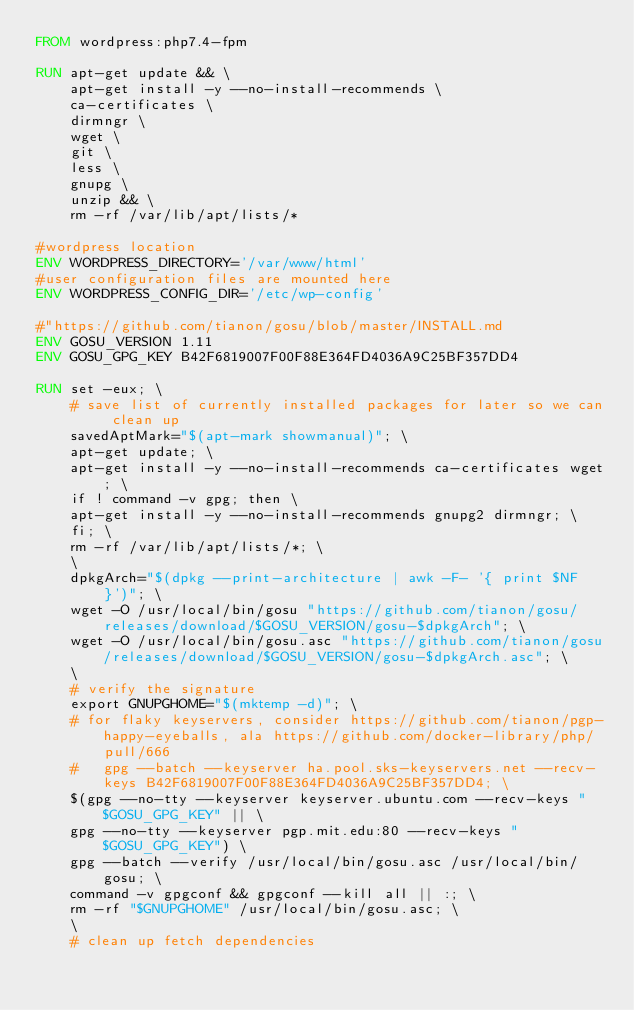<code> <loc_0><loc_0><loc_500><loc_500><_Dockerfile_>FROM wordpress:php7.4-fpm

RUN apt-get update && \
	apt-get install -y --no-install-recommends \
	ca-certificates \
	dirmngr \
	wget \
	git \
	less \
	gnupg \
	unzip && \
	rm -rf /var/lib/apt/lists/*

#wordpress location
ENV WORDPRESS_DIRECTORY='/var/www/html'
#user configuration files are mounted here
ENV WORDPRESS_CONFIG_DIR='/etc/wp-config'

#"https://github.com/tianon/gosu/blob/master/INSTALL.md
ENV GOSU_VERSION 1.11
ENV GOSU_GPG_KEY B42F6819007F00F88E364FD4036A9C25BF357DD4

RUN set -eux; \
	# save list of currently installed packages for later so we can clean up
	savedAptMark="$(apt-mark showmanual)"; \
	apt-get update; \
	apt-get install -y --no-install-recommends ca-certificates wget; \
	if ! command -v gpg; then \
	apt-get install -y --no-install-recommends gnupg2 dirmngr; \
	fi; \
	rm -rf /var/lib/apt/lists/*; \
	\
	dpkgArch="$(dpkg --print-architecture | awk -F- '{ print $NF }')"; \
	wget -O /usr/local/bin/gosu "https://github.com/tianon/gosu/releases/download/$GOSU_VERSION/gosu-$dpkgArch"; \
	wget -O /usr/local/bin/gosu.asc "https://github.com/tianon/gosu/releases/download/$GOSU_VERSION/gosu-$dpkgArch.asc"; \
	\
	# verify the signature
	export GNUPGHOME="$(mktemp -d)"; \
	# for flaky keyservers, consider https://github.com/tianon/pgp-happy-eyeballs, ala https://github.com/docker-library/php/pull/666
	#	gpg --batch --keyserver ha.pool.sks-keyservers.net --recv-keys B42F6819007F00F88E364FD4036A9C25BF357DD4; \
	$(gpg --no-tty --keyserver keyserver.ubuntu.com --recv-keys "$GOSU_GPG_KEY" || \
	gpg --no-tty --keyserver pgp.mit.edu:80 --recv-keys "$GOSU_GPG_KEY") \
	gpg --batch --verify /usr/local/bin/gosu.asc /usr/local/bin/gosu; \
	command -v gpgconf && gpgconf --kill all || :; \
	rm -rf "$GNUPGHOME" /usr/local/bin/gosu.asc; \
	\
	# clean up fetch dependencies</code> 